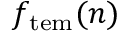Convert formula to latex. <formula><loc_0><loc_0><loc_500><loc_500>f _ { t e m } ( n )</formula> 